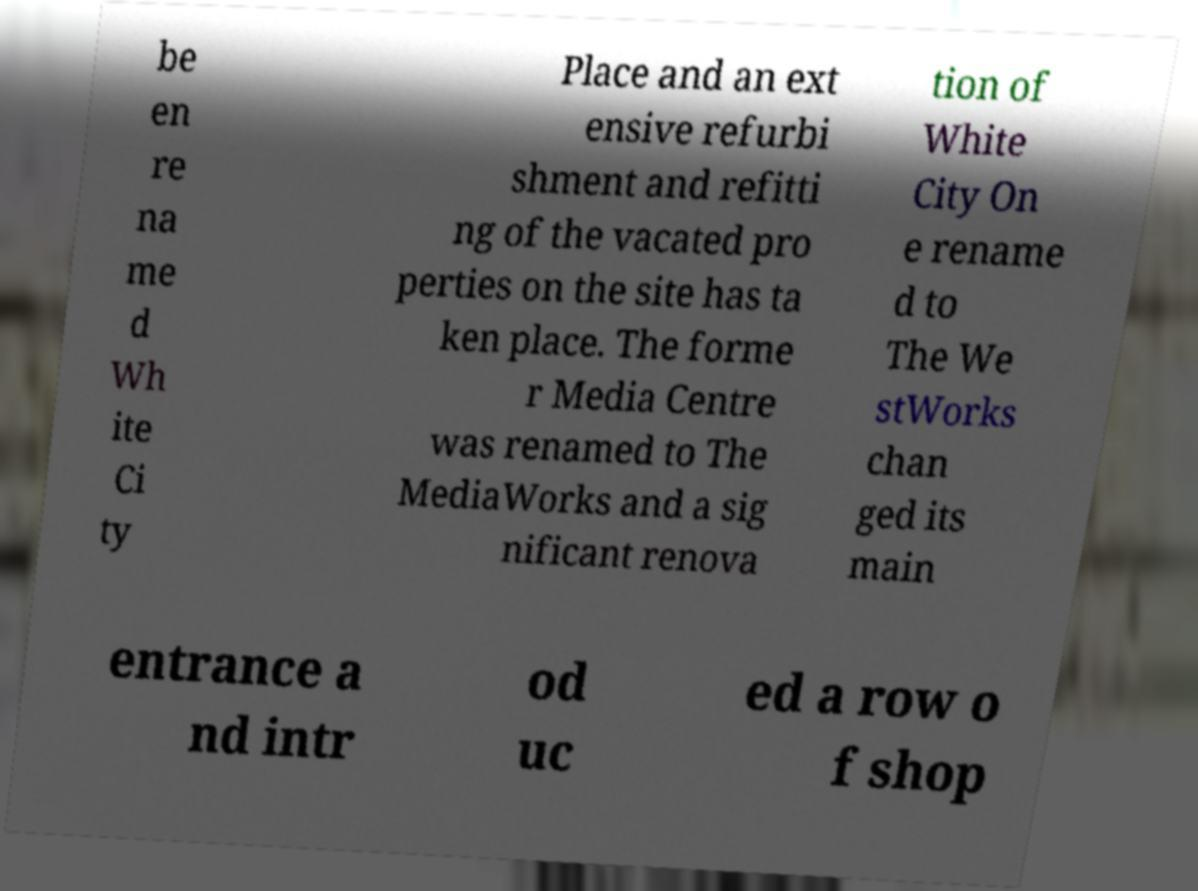There's text embedded in this image that I need extracted. Can you transcribe it verbatim? be en re na me d Wh ite Ci ty Place and an ext ensive refurbi shment and refitti ng of the vacated pro perties on the site has ta ken place. The forme r Media Centre was renamed to The MediaWorks and a sig nificant renova tion of White City On e rename d to The We stWorks chan ged its main entrance a nd intr od uc ed a row o f shop 